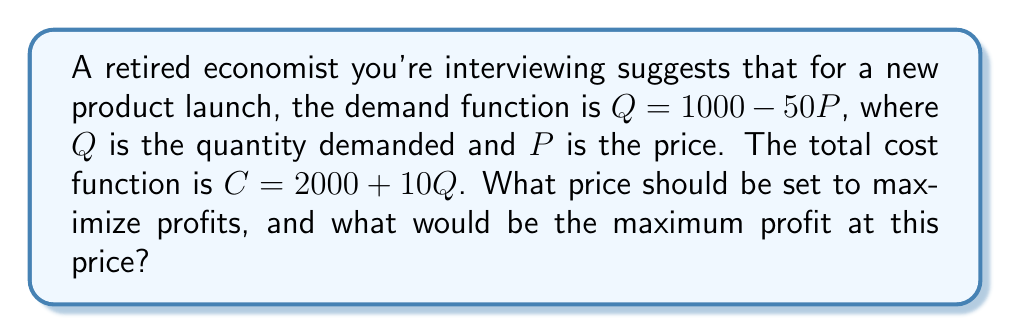Show me your answer to this math problem. To solve this problem, we'll follow these steps:

1) First, let's define the profit function. Profit ($\pi$) is revenue minus cost:
   $\pi = R - C$

2) Revenue (R) is price times quantity: $R = PQ$
   Using the demand function, we can express R in terms of P:
   $R = P(1000 - 50P) = 1000P - 50P^2$

3) The cost function is given as: $C = 2000 + 10Q$
   Substituting Q with the demand function:
   $C = 2000 + 10(1000 - 50P) = 12000 - 500P$

4) Now we can write the profit function:
   $\pi = R - C = (1000P - 50P^2) - (12000 - 500P)$
   $\pi = 1500P - 50P^2 - 12000$

5) To find the maximum profit, we differentiate $\pi$ with respect to P and set it to zero:
   $\frac{d\pi}{dP} = 1500 - 100P = 0$

6) Solving this equation:
   $1500 - 100P = 0$
   $100P = 1500$
   $P = 15$

7) To confirm this is a maximum, we can check the second derivative:
   $\frac{d^2\pi}{dP^2} = -100$, which is negative, confirming a maximum.

8) The optimal price is therefore $15.

9) To find the maximum profit, we substitute P = 15 into our profit function:
   $\pi = 1500(15) - 50(15)^2 - 12000$
   $\pi = 22500 - 11250 - 12000 = -750$

Therefore, the maximum profit is $-750.
Answer: The optimal price to maximize profits is $15, and the maximum profit at this price is $-750. 